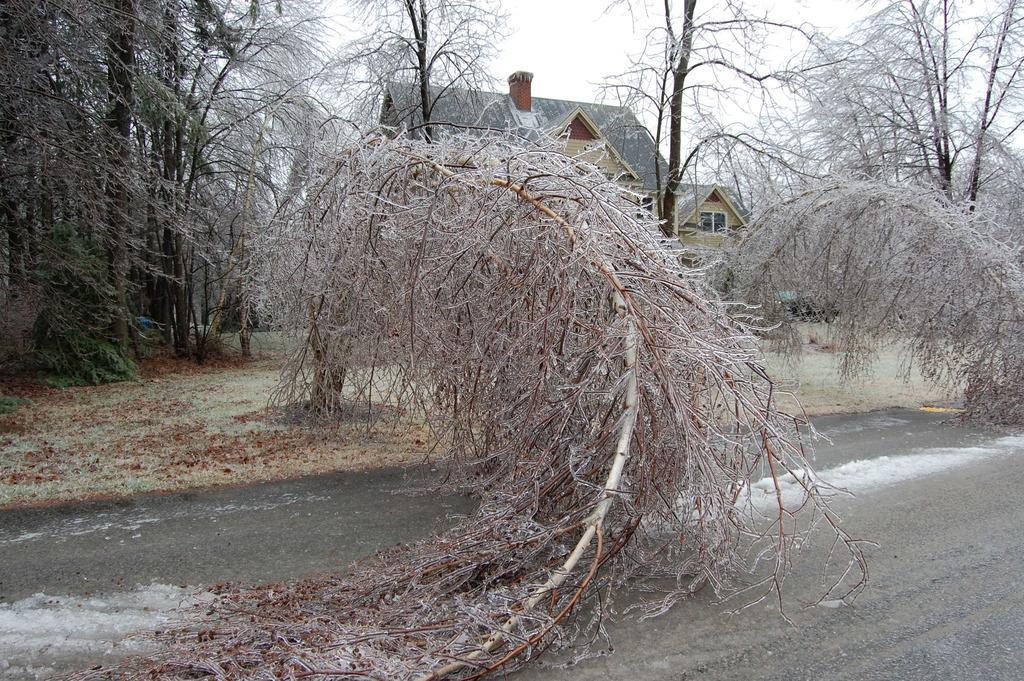Please provide a concise description of this image. At the bottom of the image I can see the road. On the road I can see the snow. In the background, I can see many trees and a house. The trees are filled with the snow. 